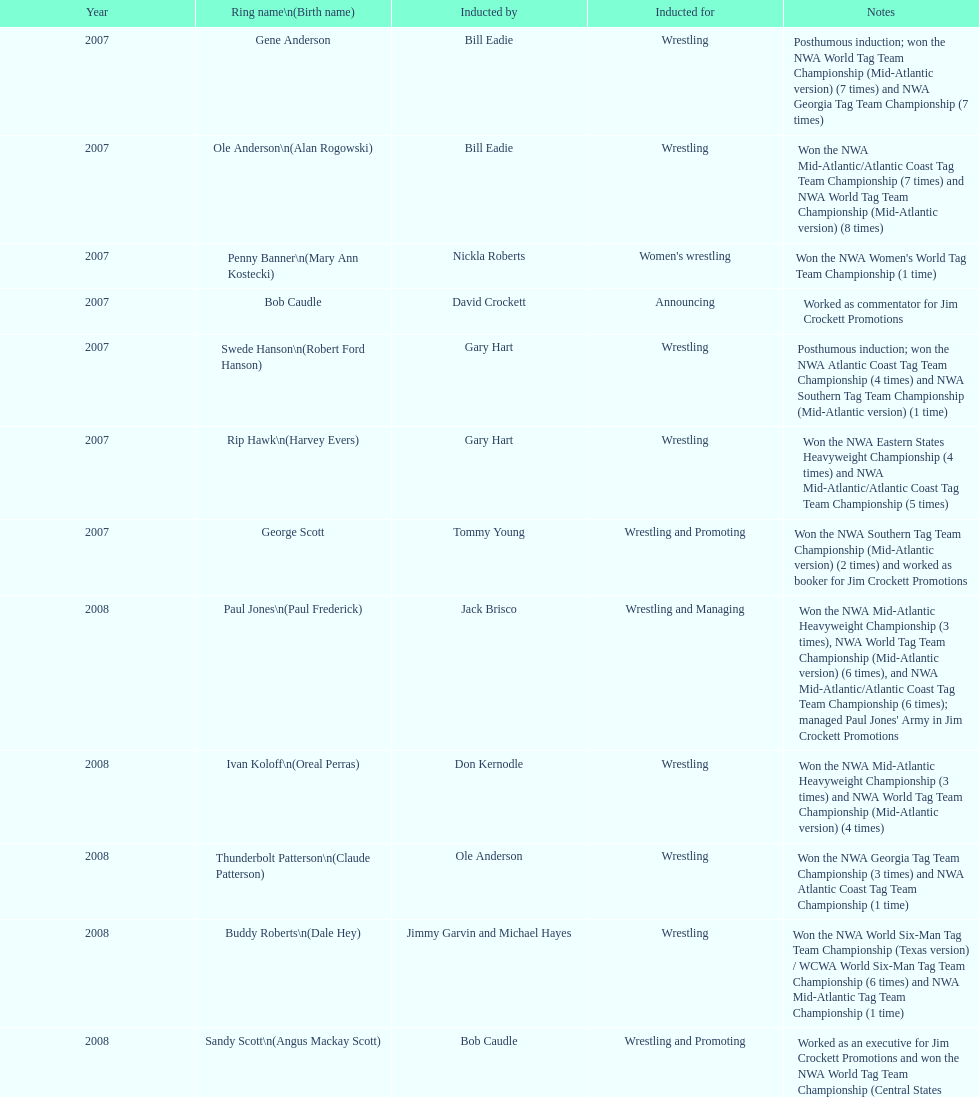Bob caudle was an announcer, who was the other one? Lance Russell. 